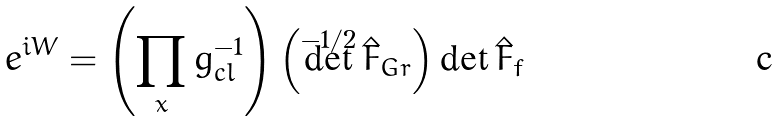Convert formula to latex. <formula><loc_0><loc_0><loc_500><loc_500>e ^ { i W } = \left ( \prod _ { x } g _ { c l } ^ { - 1 } \right ) \left ( \det ^ { - 1 / 2 } \hat { F } _ { G r } \right ) \det \hat { F } _ { f }</formula> 